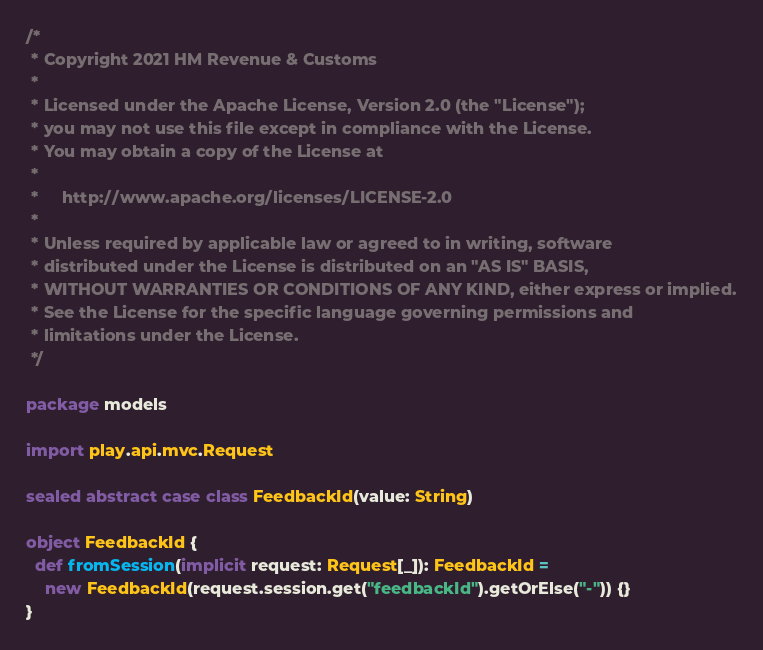Convert code to text. <code><loc_0><loc_0><loc_500><loc_500><_Scala_>/*
 * Copyright 2021 HM Revenue & Customs
 *
 * Licensed under the Apache License, Version 2.0 (the "License");
 * you may not use this file except in compliance with the License.
 * You may obtain a copy of the License at
 *
 *     http://www.apache.org/licenses/LICENSE-2.0
 *
 * Unless required by applicable law or agreed to in writing, software
 * distributed under the License is distributed on an "AS IS" BASIS,
 * WITHOUT WARRANTIES OR CONDITIONS OF ANY KIND, either express or implied.
 * See the License for the specific language governing permissions and
 * limitations under the License.
 */

package models

import play.api.mvc.Request

sealed abstract case class FeedbackId(value: String)

object FeedbackId {
  def fromSession(implicit request: Request[_]): FeedbackId =
    new FeedbackId(request.session.get("feedbackId").getOrElse("-")) {}
}
</code> 